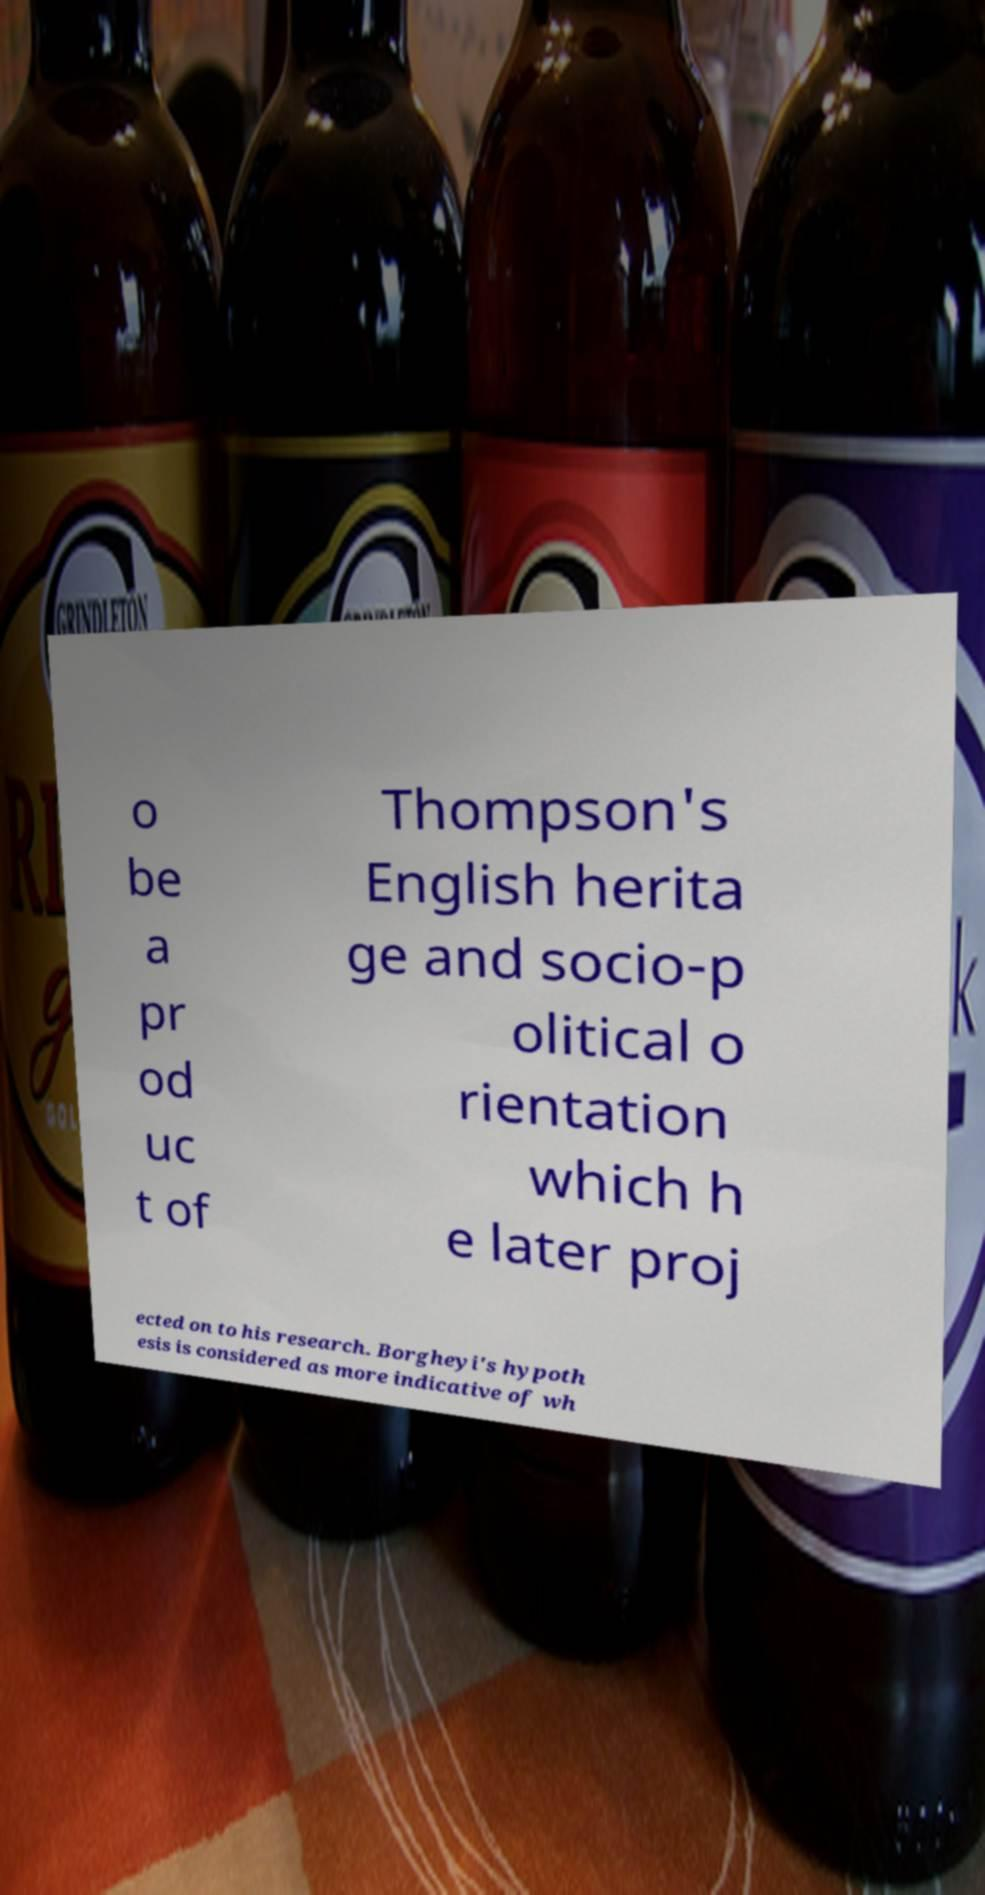Can you accurately transcribe the text from the provided image for me? o be a pr od uc t of Thompson's English herita ge and socio-p olitical o rientation which h e later proj ected on to his research. Borgheyi's hypoth esis is considered as more indicative of wh 